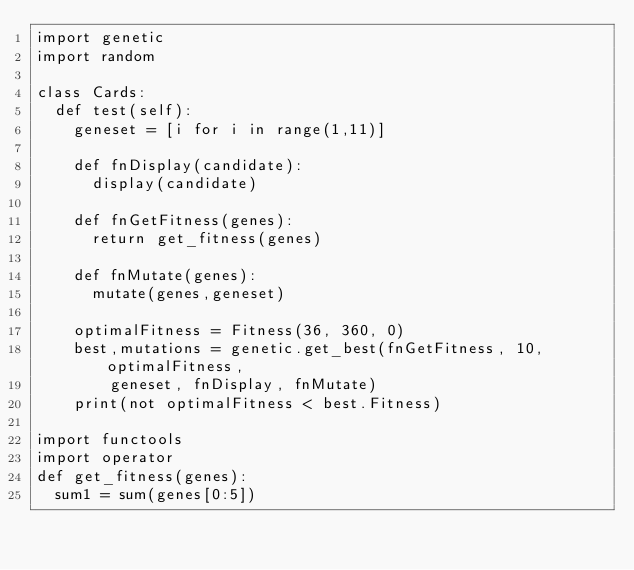Convert code to text. <code><loc_0><loc_0><loc_500><loc_500><_Python_>import genetic 
import random

class Cards:
	def test(self):
		geneset = [i for i in range(1,11)]

		def fnDisplay(candidate):
			display(candidate)
		
		def fnGetFitness(genes):
			return get_fitness(genes)

		def fnMutate(genes):
			mutate(genes,geneset)

		optimalFitness = Fitness(36, 360, 0)
		best,mutations = genetic.get_best(fnGetFitness, 10, optimalFitness,
				geneset, fnDisplay, fnMutate)
		print(not optimalFitness < best.Fitness)

import functools
import operator
def get_fitness(genes):
	sum1 = sum(genes[0:5])</code> 